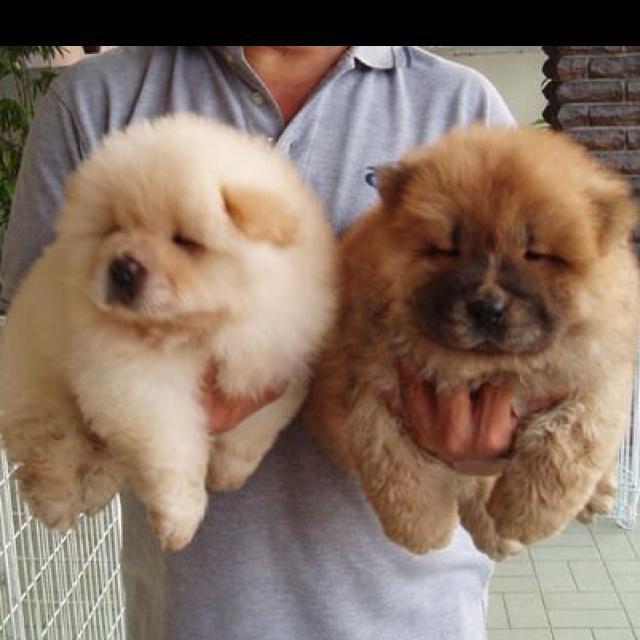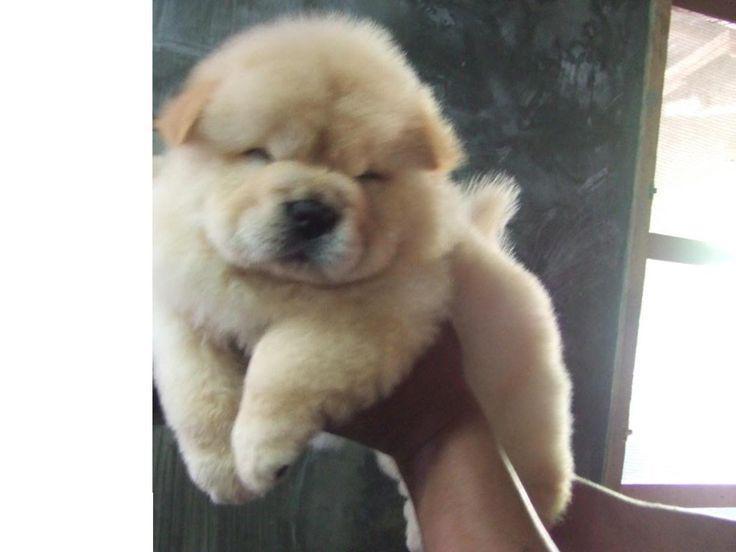The first image is the image on the left, the second image is the image on the right. For the images displayed, is the sentence "There are three animals" factually correct? Answer yes or no. Yes. The first image is the image on the left, the second image is the image on the right. Analyze the images presented: Is the assertion "There are no more than two dogs in the image on the left." valid? Answer yes or no. Yes. 